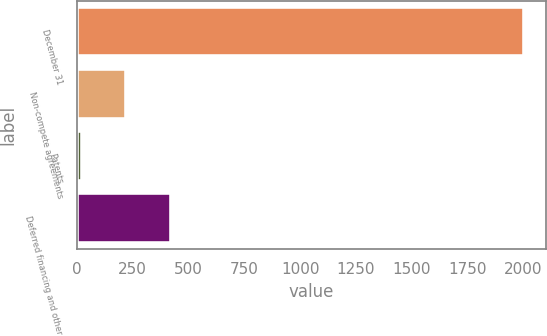Convert chart to OTSL. <chart><loc_0><loc_0><loc_500><loc_500><bar_chart><fcel>December 31<fcel>Non-compete agreements<fcel>Patents<fcel>Deferred financing and other<nl><fcel>2001<fcel>221.97<fcel>24.3<fcel>419.64<nl></chart> 